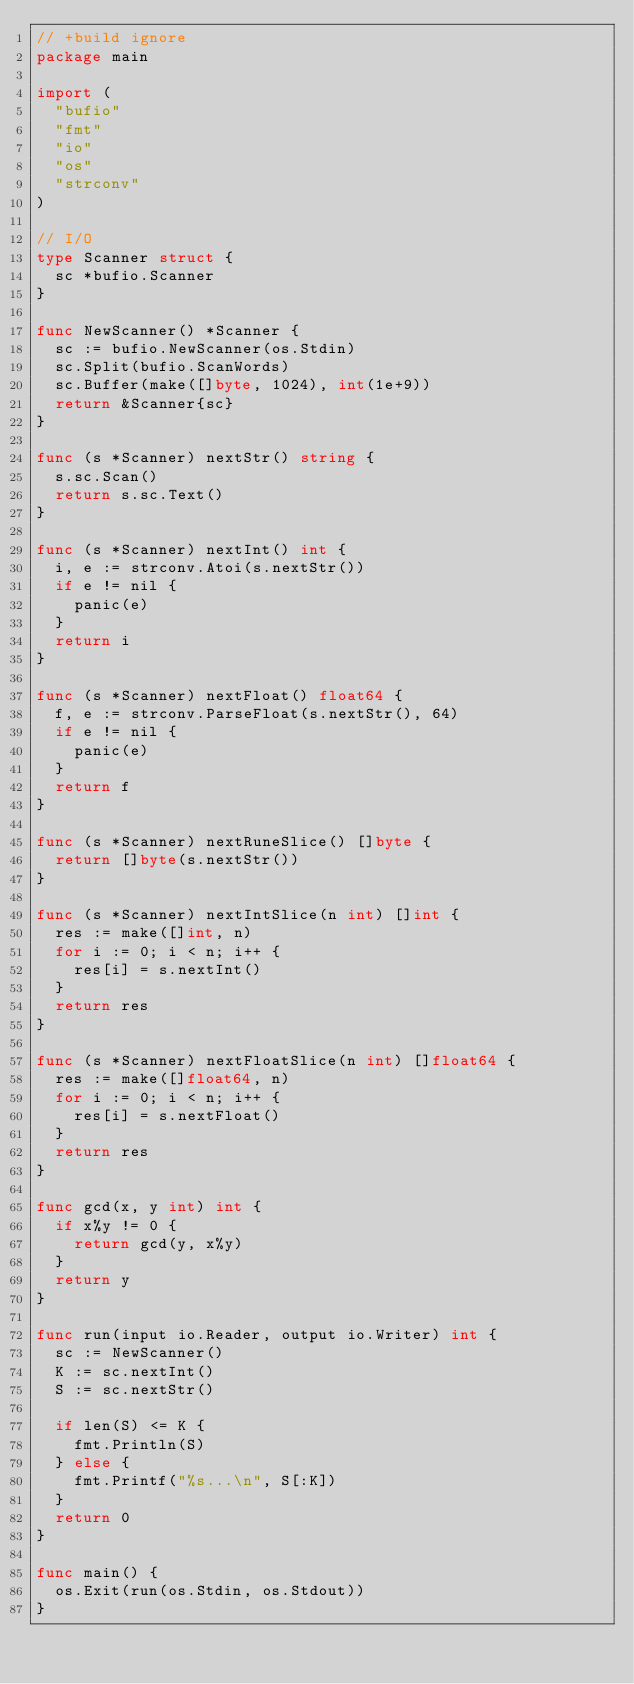<code> <loc_0><loc_0><loc_500><loc_500><_Go_>// +build ignore
package main

import (
	"bufio"
	"fmt"
	"io"
	"os"
	"strconv"
)

// I/O
type Scanner struct {
	sc *bufio.Scanner
}

func NewScanner() *Scanner {
	sc := bufio.NewScanner(os.Stdin)
	sc.Split(bufio.ScanWords)
	sc.Buffer(make([]byte, 1024), int(1e+9))
	return &Scanner{sc}
}

func (s *Scanner) nextStr() string {
	s.sc.Scan()
	return s.sc.Text()
}

func (s *Scanner) nextInt() int {
	i, e := strconv.Atoi(s.nextStr())
	if e != nil {
		panic(e)
	}
	return i
}

func (s *Scanner) nextFloat() float64 {
	f, e := strconv.ParseFloat(s.nextStr(), 64)
	if e != nil {
		panic(e)
	}
	return f
}

func (s *Scanner) nextRuneSlice() []byte {
	return []byte(s.nextStr())
}

func (s *Scanner) nextIntSlice(n int) []int {
	res := make([]int, n)
	for i := 0; i < n; i++ {
		res[i] = s.nextInt()
	}
	return res
}

func (s *Scanner) nextFloatSlice(n int) []float64 {
	res := make([]float64, n)
	for i := 0; i < n; i++ {
		res[i] = s.nextFloat()
	}
	return res
}

func gcd(x, y int) int {
	if x%y != 0 {
		return gcd(y, x%y)
	}
	return y
}

func run(input io.Reader, output io.Writer) int {
	sc := NewScanner()
	K := sc.nextInt()
	S := sc.nextStr()

	if len(S) <= K {
		fmt.Println(S)
	} else {
		fmt.Printf("%s...\n", S[:K])
	}
	return 0
}

func main() {
	os.Exit(run(os.Stdin, os.Stdout))
}
</code> 